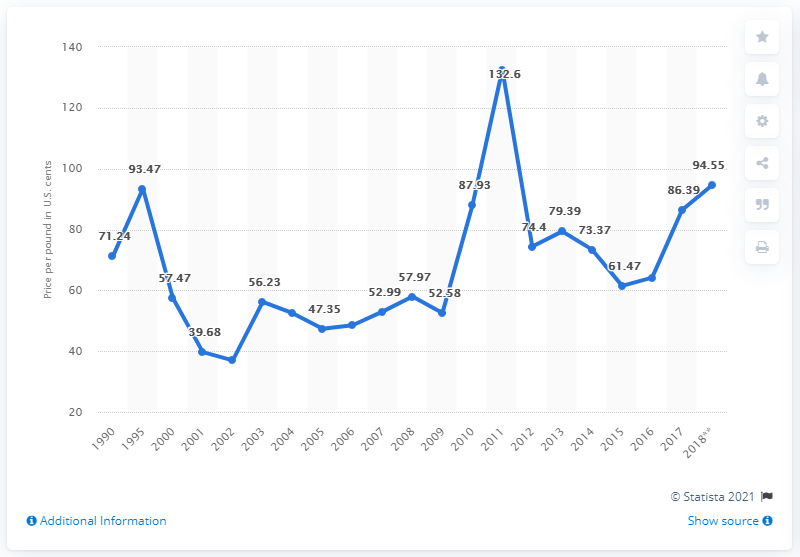Identify some key points in this picture. The total upland spot cotton price in the United States fluctuated between 2017 and 2018, with a notable increase from 180.94 in 2017 to 2018. The price of upland cotton in the United States in 2017 was 86.39 cents per pound. 